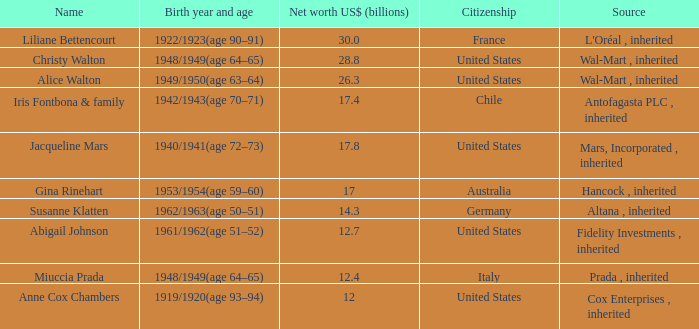What's the source of wealth of the person worth $17 billion? Hancock , inherited. 